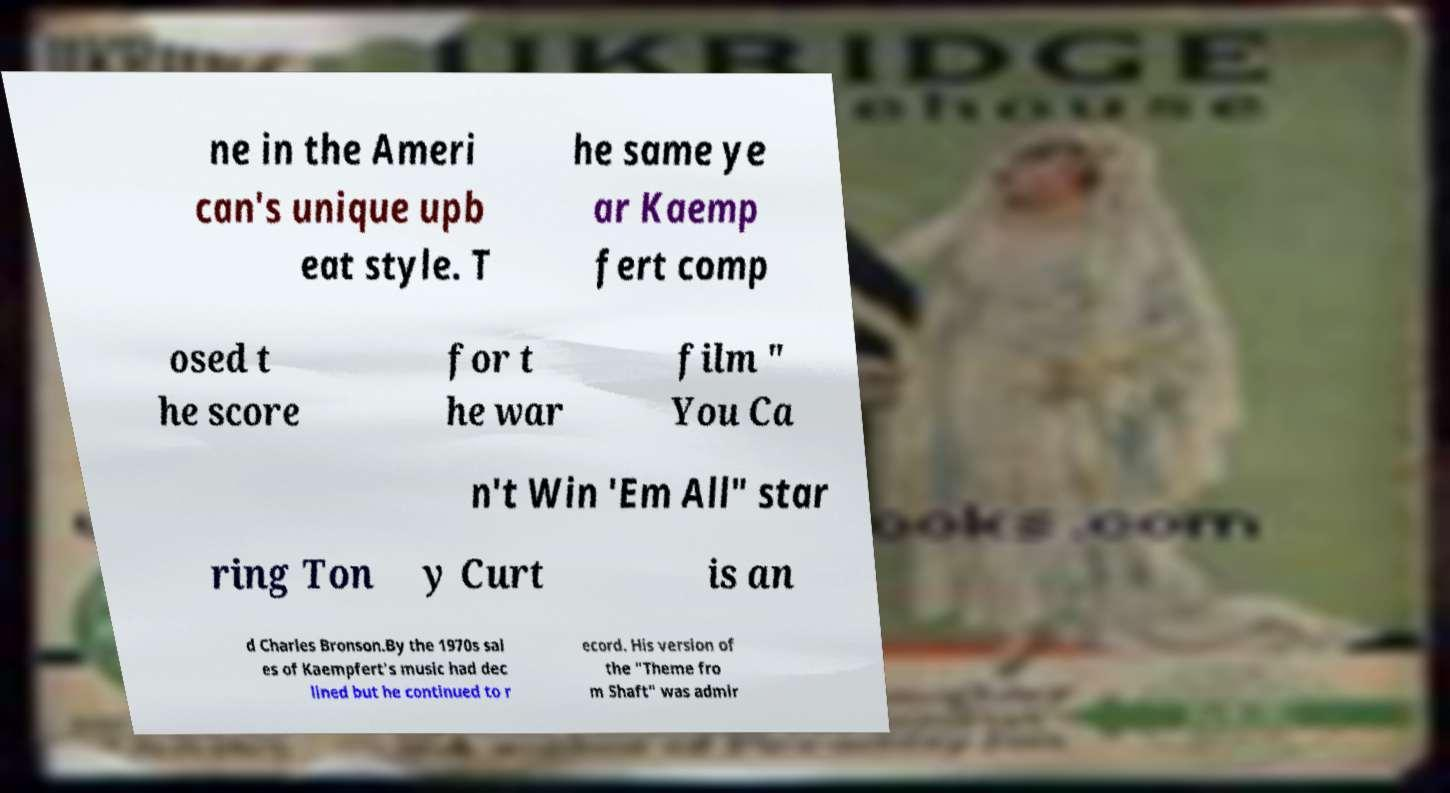Please identify and transcribe the text found in this image. ne in the Ameri can's unique upb eat style. T he same ye ar Kaemp fert comp osed t he score for t he war film " You Ca n't Win 'Em All" star ring Ton y Curt is an d Charles Bronson.By the 1970s sal es of Kaempfert's music had dec lined but he continued to r ecord. His version of the "Theme fro m Shaft" was admir 